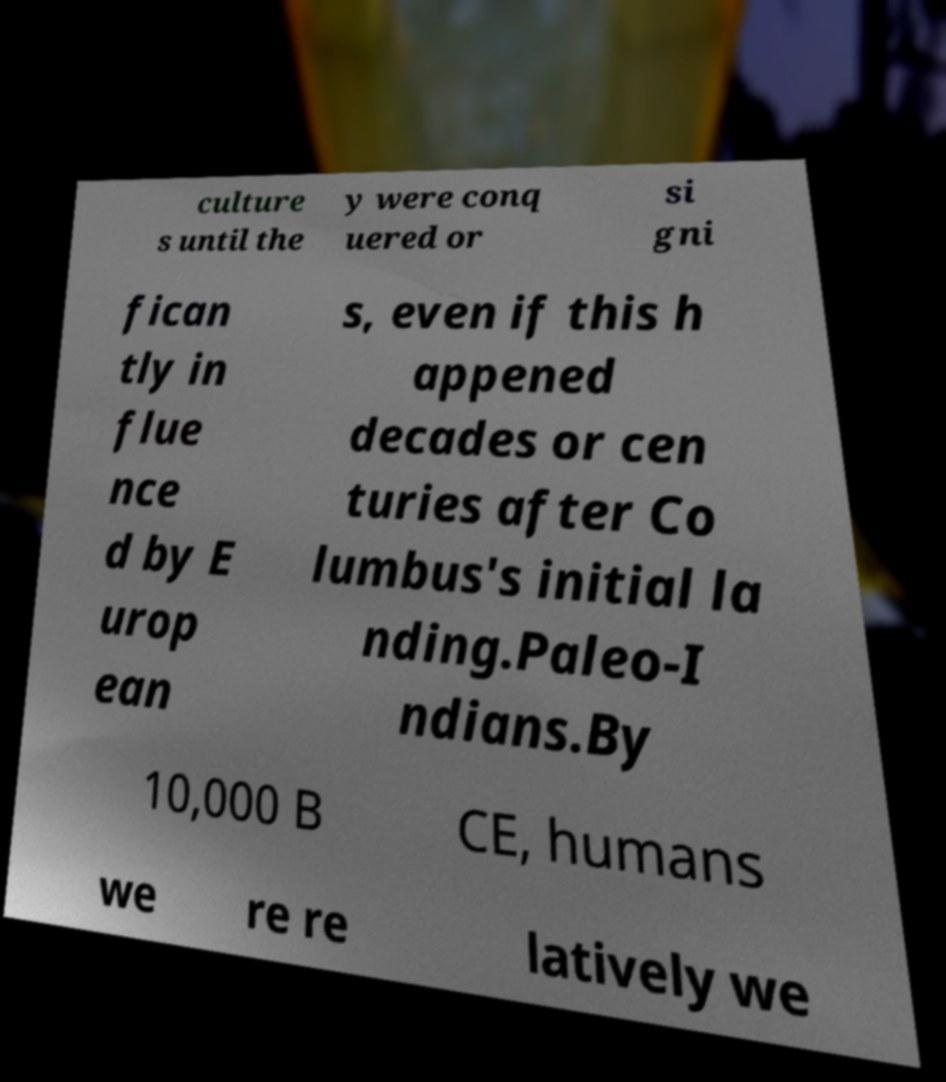Could you extract and type out the text from this image? culture s until the y were conq uered or si gni fican tly in flue nce d by E urop ean s, even if this h appened decades or cen turies after Co lumbus's initial la nding.Paleo-I ndians.By 10,000 B CE, humans we re re latively we 